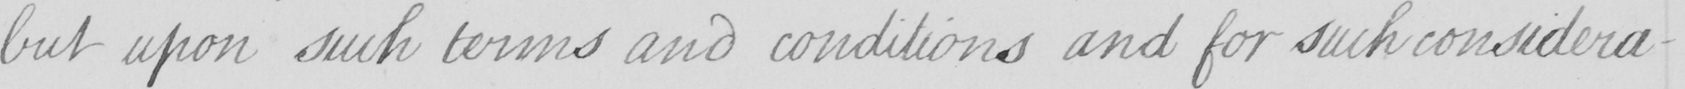Can you tell me what this handwritten text says? but upon such terms and conditions and for such considera- 